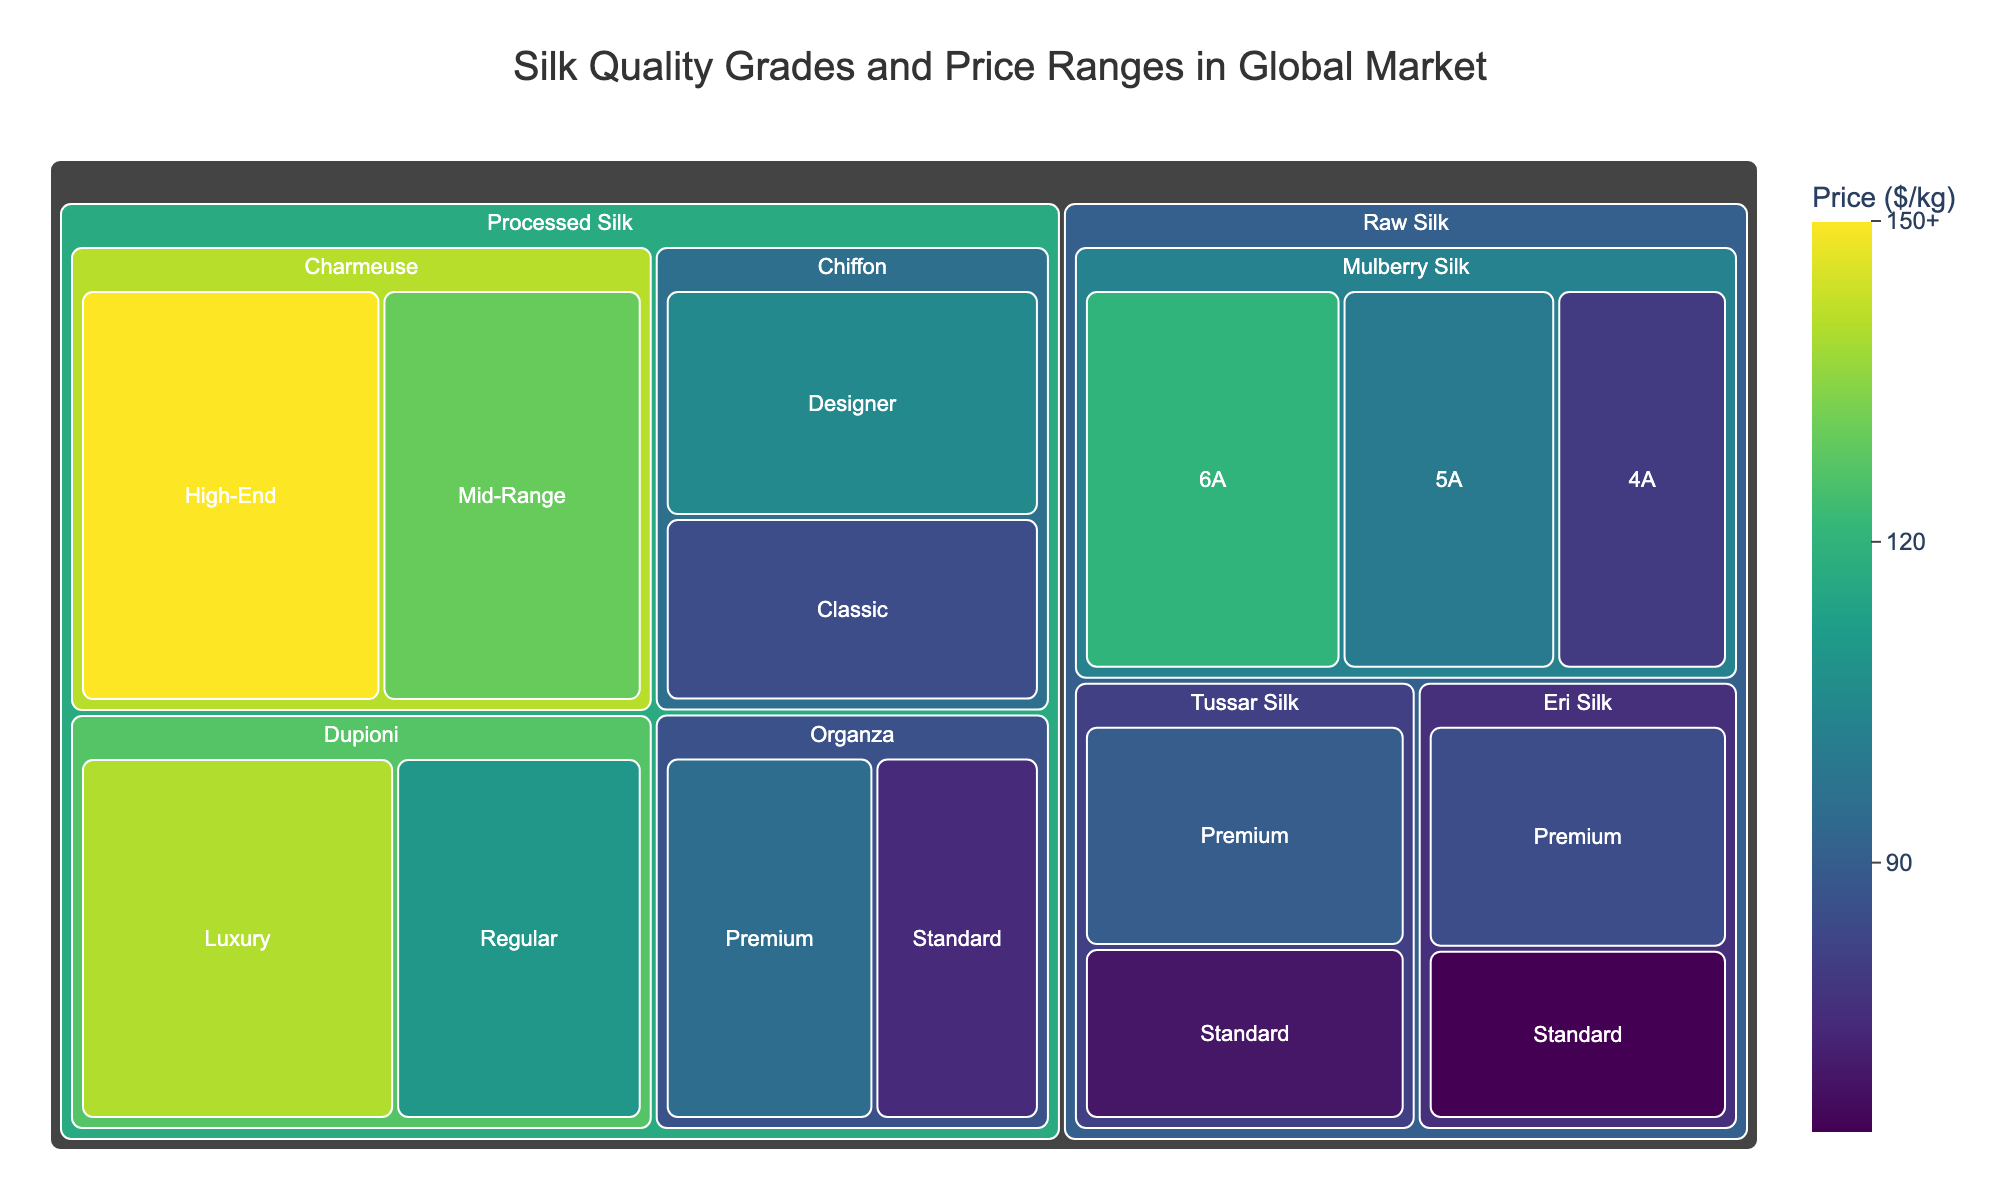What is the price range for Mulberry Silk with 6A quality? Look for the Mulberry Silk under Raw Silk and find the 6A quality, the price is indicated on the treemap
Answer: $120 Which subcategory of Raw Silk has the lowest standard quality price? Compare the standard quality prices under the Raw Silk category. Eri Silk Standard is priced at $65, which is the lowest
Answer: Eri Silk What is the highest price among the Processed Silk subcategories? Identify the highest price under the Processed Silk category, which is Charmeuse High-End priced at $150
Answer: $150 Between Premium Tussar Silk and Premium Eri Silk, which one is more expensive? Compare the prices: Premium Tussar Silk is $90, and Premium Eri Silk is $85, so Tussar Silk is more expensive
Answer: Tussar Silk What is the average price of 4A, 5A, and 6A qualities of Mulberry Silk? Calculate the average by adding the prices ($80 + $100 + $120) and dividing by 3. The average is $300/3
Answer: $100 How much more expensive is High-End Charmeuse compared to Standard Organza? Subtract the price of Standard Organza ($75) from High-End Charmeuse ($150). The difference is $150 - $75
Answer: $75 List all the subcategories of Processed Silk that have a price above $100. Identify the Processed Silk subcategories with prices above $100: Charmeuse (High-End) $150, Dupioni (Luxury) $140, Charmeuse (Mid-Range) $130, Dupioni (Regular) $110, and Chiffon (Designer) $105
Answer: Charmeuse (High-End), Dupioni (Luxury), Charmeuse (Mid-Range), Dupioni (Regular), Chiffon (Designer) Which Raw Silk subcategory has the highest price, and what is that price? Look for the highest price under Raw Silk. Mulberry Silk with 6A quality has the highest price at $120
Answer: Mulberry Silk, $120 Between Dupioni Regular and Chiffon Classic, which one is cheaper and by how much? Compare the prices: Dupioni Regular is $110, and Chiffon Classic is $85. The difference is $110 - $85
Answer: Chiffon Classic, $25 How many quality grades does Tussar Silk have, and what are their prices? Check the number of quality grades under Tussar Silk: two (Premium and Standard) with prices $90 and $70 respectively
Answer: 2 grades, $90 and $70 